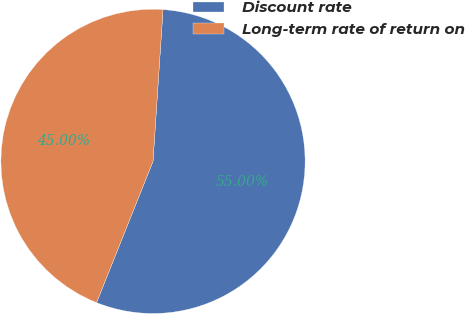Convert chart. <chart><loc_0><loc_0><loc_500><loc_500><pie_chart><fcel>Discount rate<fcel>Long-term rate of return on<nl><fcel>55.0%<fcel>45.0%<nl></chart> 